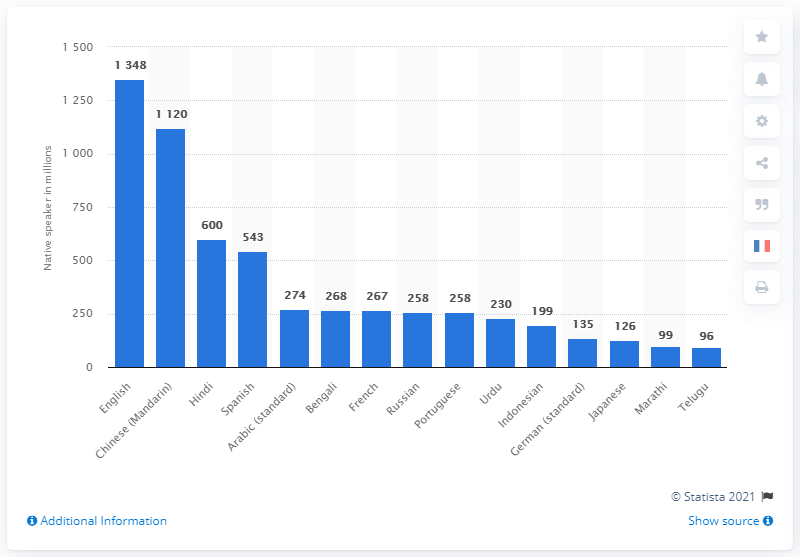Point out several critical features in this image. In 2021, it is estimated that 1348 people spoke English as a second language. 